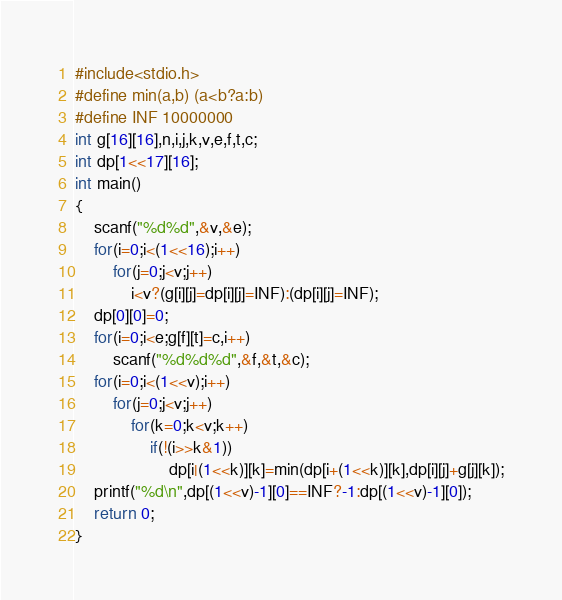<code> <loc_0><loc_0><loc_500><loc_500><_C_>#include<stdio.h>
#define min(a,b) (a<b?a:b)
#define INF 10000000
int g[16][16],n,i,j,k,v,e,f,t,c;
int dp[1<<17][16];
int main()
{
	scanf("%d%d",&v,&e);
	for(i=0;i<(1<<16);i++)
		for(j=0;j<v;j++)
			i<v?(g[i][j]=dp[i][j]=INF):(dp[i][j]=INF);
	dp[0][0]=0;
	for(i=0;i<e;g[f][t]=c,i++)
		scanf("%d%d%d",&f,&t,&c);
	for(i=0;i<(1<<v);i++)
		for(j=0;j<v;j++)
			for(k=0;k<v;k++)
				if(!(i>>k&1))
					dp[i|(1<<k)][k]=min(dp[i+(1<<k)][k],dp[i][j]+g[j][k]);
	printf("%d\n",dp[(1<<v)-1][0]==INF?-1:dp[(1<<v)-1][0]);
	return 0;
}</code> 